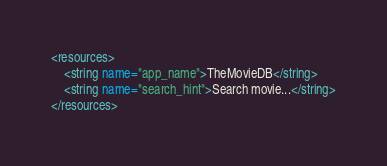<code> <loc_0><loc_0><loc_500><loc_500><_XML_><resources>
    <string name="app_name">TheMovieDB</string>
    <string name="search_hint">Search movie...</string>
</resources>
</code> 